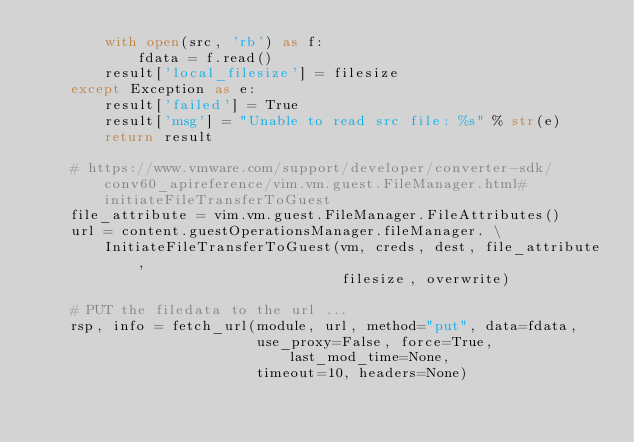<code> <loc_0><loc_0><loc_500><loc_500><_Python_>        with open(src, 'rb') as f:
            fdata = f.read()
        result['local_filesize'] = filesize
    except Exception as e:
        result['failed'] = True
        result['msg'] = "Unable to read src file: %s" % str(e)
        return result

    # https://www.vmware.com/support/developer/converter-sdk/conv60_apireference/vim.vm.guest.FileManager.html#initiateFileTransferToGuest
    file_attribute = vim.vm.guest.FileManager.FileAttributes()
    url = content.guestOperationsManager.fileManager. \
        InitiateFileTransferToGuest(vm, creds, dest, file_attribute,
                                    filesize, overwrite)

    # PUT the filedata to the url ...
    rsp, info = fetch_url(module, url, method="put", data=fdata,
                          use_proxy=False, force=True, last_mod_time=None,
                          timeout=10, headers=None)
</code> 